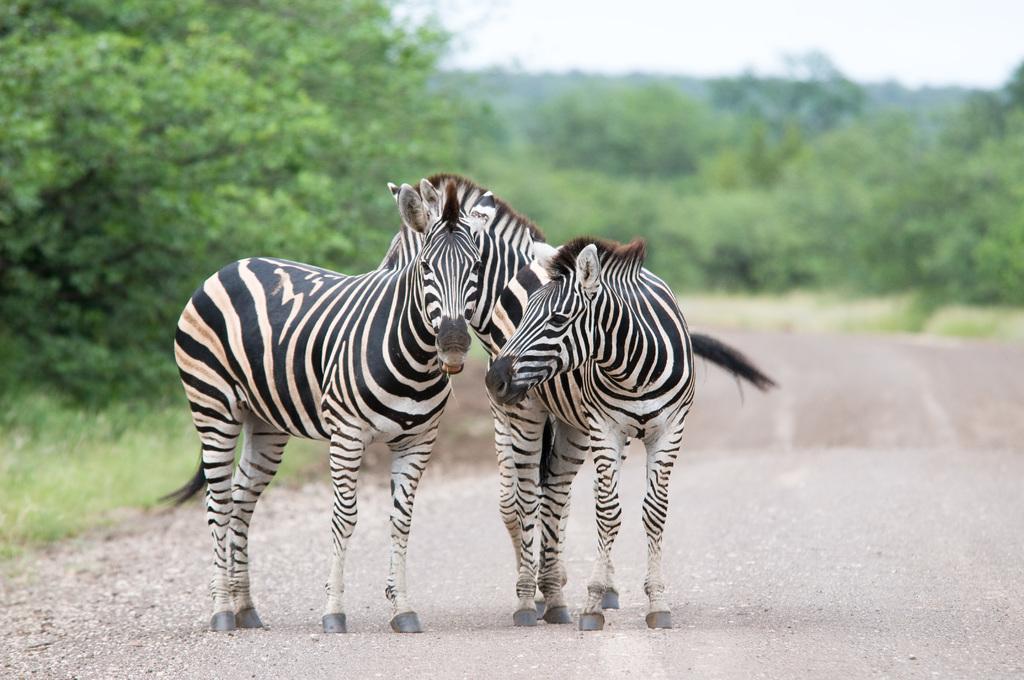In one or two sentences, can you explain what this image depicts? In the center of the image we can see a few zebras on the road. In the background, we can see the sky, clouds, trees, grass etc. 